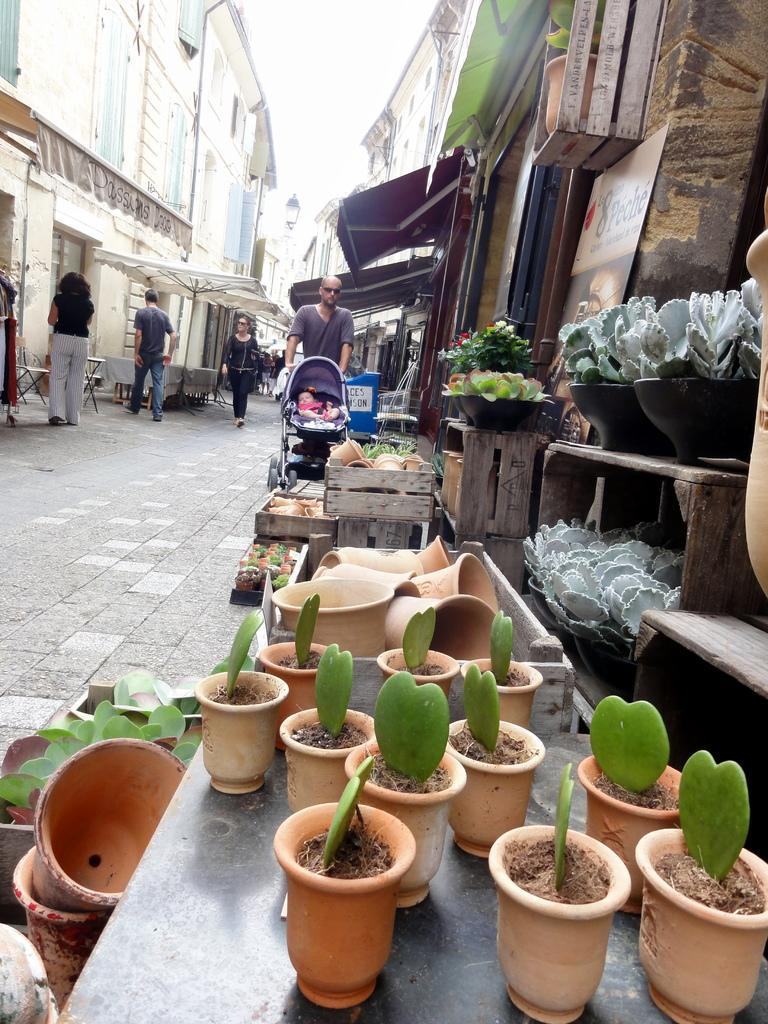What type of objects are in the pots in the image? There are plants in pots in the image. Can you describe the background of the image? There are more plants in pots and buildings visible in the background of the image. What else can be seen in the image? There are people standing in the image. What type of prose is being recited by the women in the image? There are no women or prose present in the image; it features plants in pots and people standing in the foreground and background. 